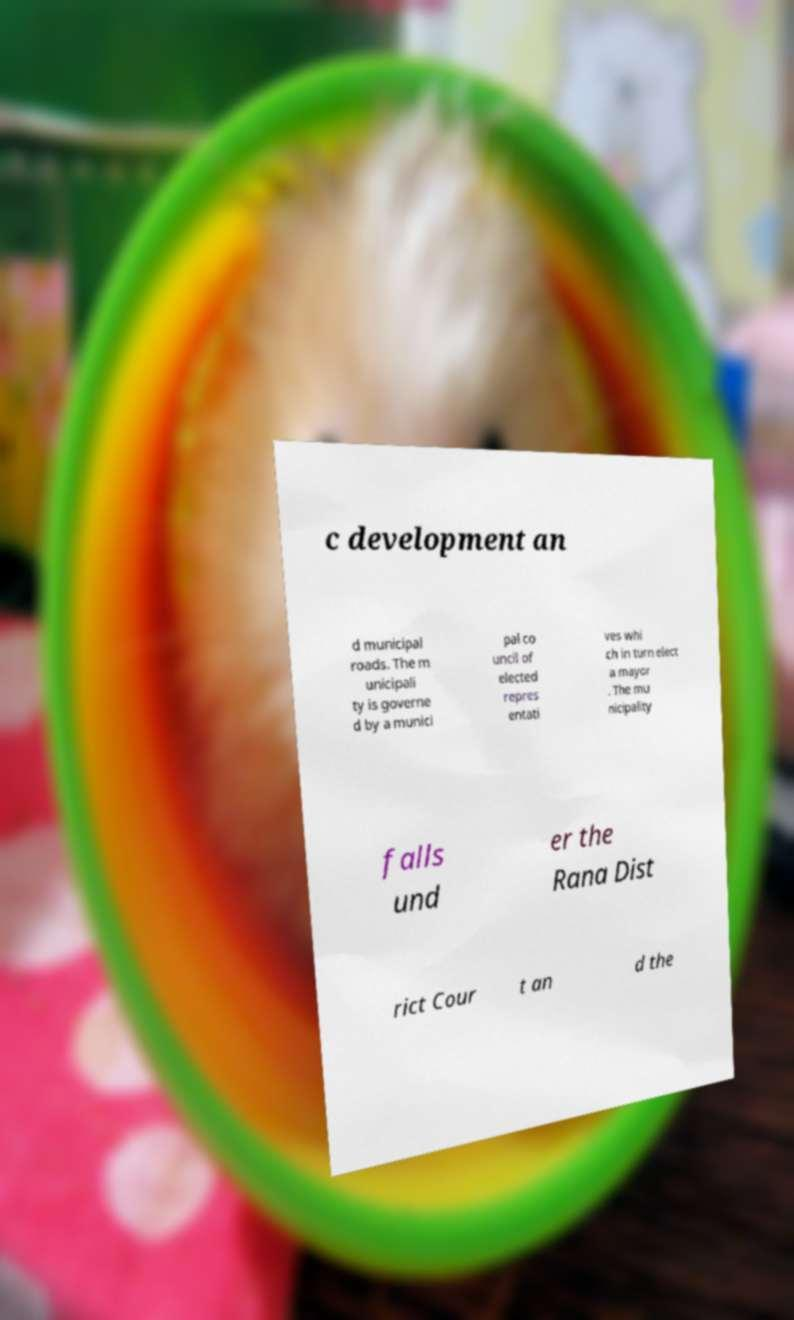What messages or text are displayed in this image? I need them in a readable, typed format. c development an d municipal roads. The m unicipali ty is governe d by a munici pal co uncil of elected repres entati ves whi ch in turn elect a mayor . The mu nicipality falls und er the Rana Dist rict Cour t an d the 